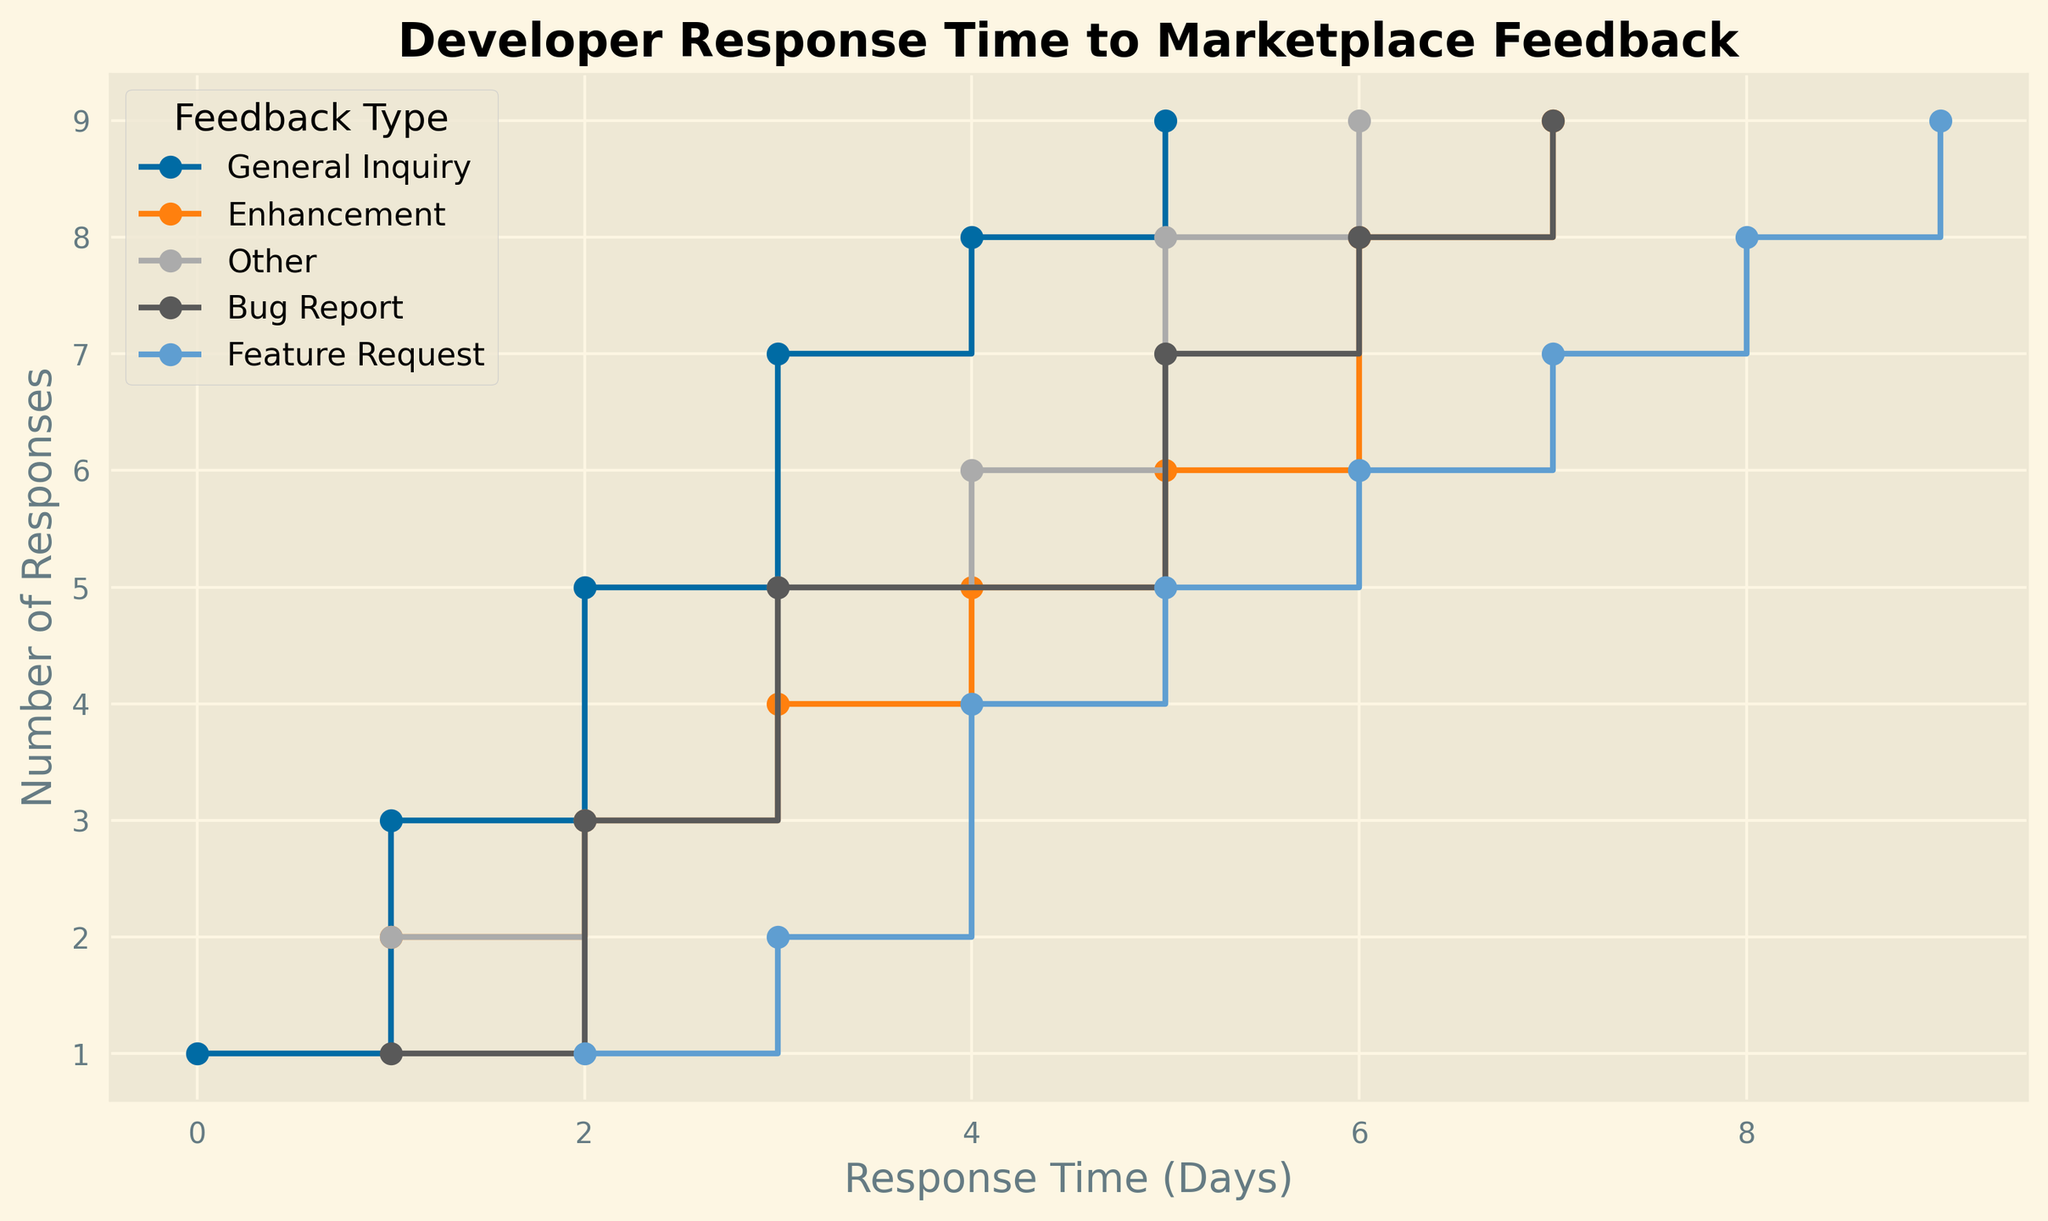What is the maximum response time for a Bug Report? Find the point where the Bug Report line ends on the x-axis.
Answer: 7 days Which feedback type has the shortest maximum response time? Compare the ending points of all feedback types on the x-axis.
Answer: General Inquiry How many times did the developer respond to Feature Requests exactly within 4 days? Locate the x-axis point at 4 days, see the cumulative count for Feature Requests.
Answer: 2 How many responses were given to General Inquiries within 3 days? Find the point at 3 days on the x-axis and read the cumulative count for General Inquiries.
Answer: 6 What is the difference in maximum response time between Feature Requests and Other feedback types? Find the end points on the x-axis for both Feature Requests and Other, then subtract the smaller from the larger.
Answer: 3 days Which feedback type has the steepest rise within the first 3 days? Observe which line has the most significant vertical increase in the first 3 days.
Answer: Enhancement Is there any feedback type that received no response after 6 days? See if any lines stop or stay flat after the 6-day mark on the x-axis.
Answer: Yes, General Inquiry Which two feedback types have the same number of responses by day 5? Compare cumulative counts at day 5 for all feedback types.
Answer: Bug Report and General Inquiry What feedback type took the longest time to get the first response? Identify the feedback type whose line starts furthest from the origin on the x-axis.
Answer: General Inquiry 